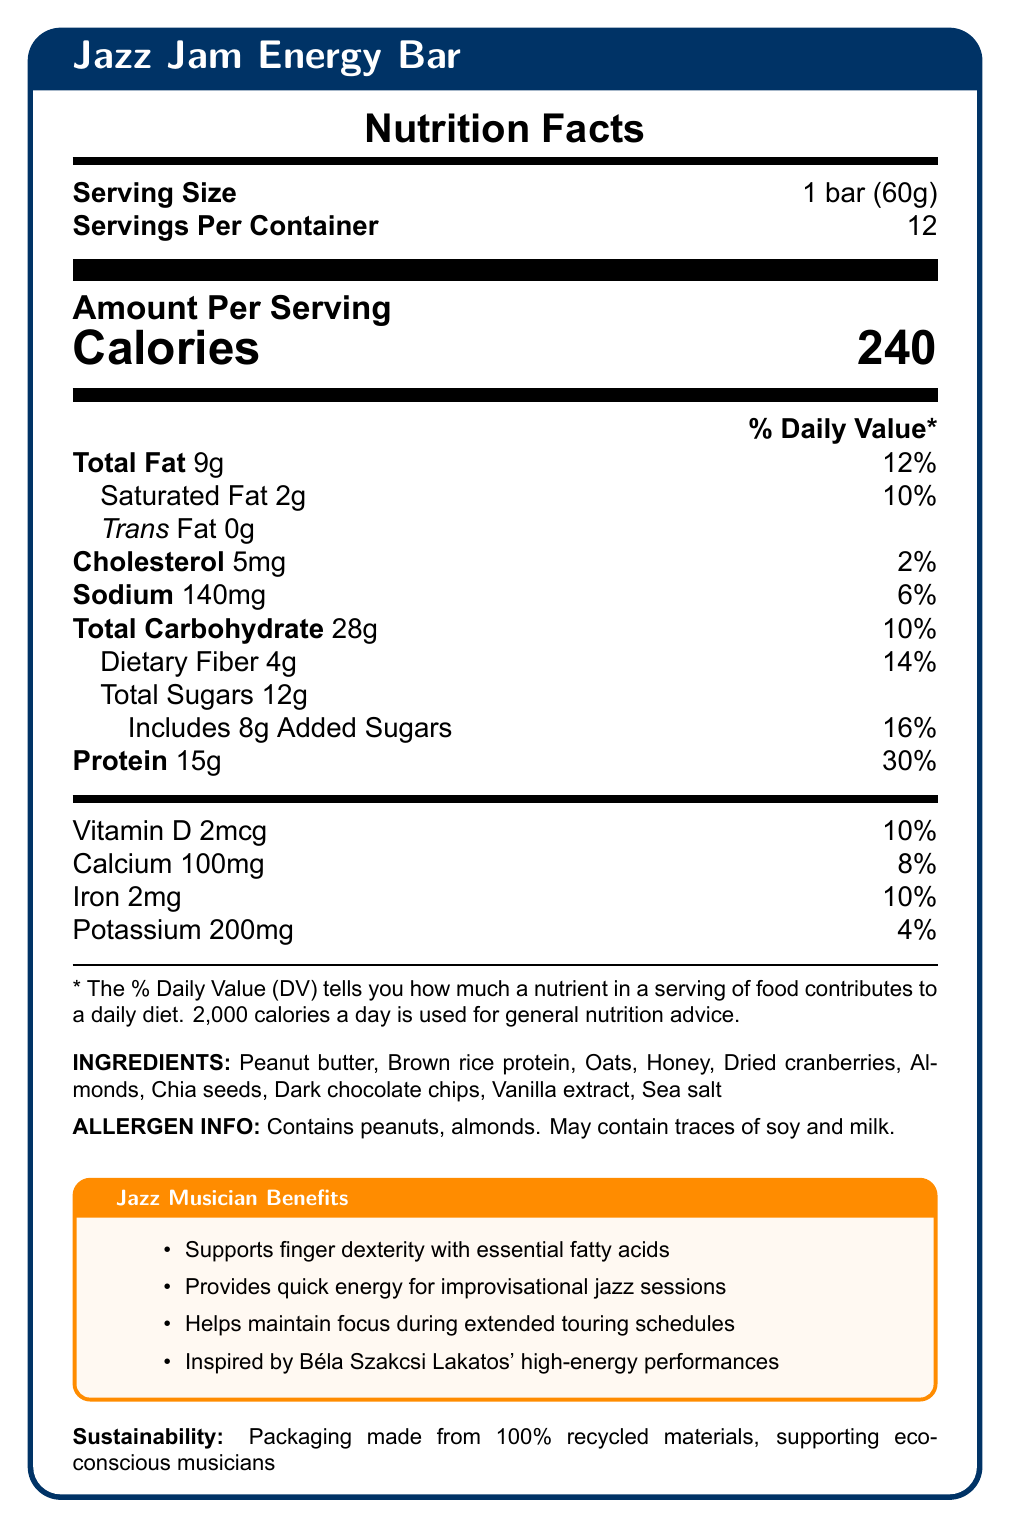what is the serving size? The serving size is clearly listed as "1 bar (60g)" in the table under "Serving Size".
Answer: 1 bar (60g) how many servings are in a container? The number of servings per container is provided under "Servings Per Container" as 12.
Answer: 12 what is the amount of protein per serving? The amount of protein per serving is listed as "Protein 15g" in the "Amount Per Serving" section.
Answer: 15g how many calories are in each serving? The calorie content per serving is prominently displayed under "Calories" as 240.
Answer: 240 what allergens does the bar contain? The allergen information is specified at the bottom under "ALLERGEN INFO".
Answer: Contains peanuts, almonds. May contain traces of soy and milk. how much vitamin D is in one serving? The amount of vitamin D is listed as "Vitamin D 2mcg" along with its daily value percentage.
Answer: 2mcg what are the main musician benefits of the Jazz Jam Energy Bar? These benefits are detailed in the "Jazz Musician Benefits" box.
Answer: Supports finger dexterity, provides quick energy, helps maintain focus, inspired by Béla Szakcsi Lakatos. how much total fat is in one bar? A. 8g B. 9g C. 10g D. 12g The total fat per bar is listed as "Total Fat 9g".
Answer: B. 9g what is the percentage daily value of calcium in one serving? A. 4% B. 6% C. 8% D. 10% The percentage daily value of calcium is listed as 8% next to "Calcium 100mg".
Answer: C. 8% does the Jazz Jam Energy Bar support eco-conscious musicians? The document states that the packaging is made from 100% recycled materials, supporting eco-conscious musicians.
Answer: Yes provide a brief summary of the Jazz Jam Energy Bar's nutritional information and benefits for musicians. It condenses key points from the "Nutrition Facts," ingredients, and musician benefits sections.
Answer: The Jazz Jam Energy Bar contains 240 calories per bar, with significant protein content (15g), complex carbohydrates, and various vitamins and minerals. It is designed to support musicians with benefits like sustained energy, focus, and dexterity. The packaging is environmentally friendly. what is the specific energy source used in the Jazz Jam Energy Bar to provide lasting stamina? The document mentions complex carbohydrates for lasting stamina but does not specify the exact source of these carbohydrates.
Answer: Cannot be determined 